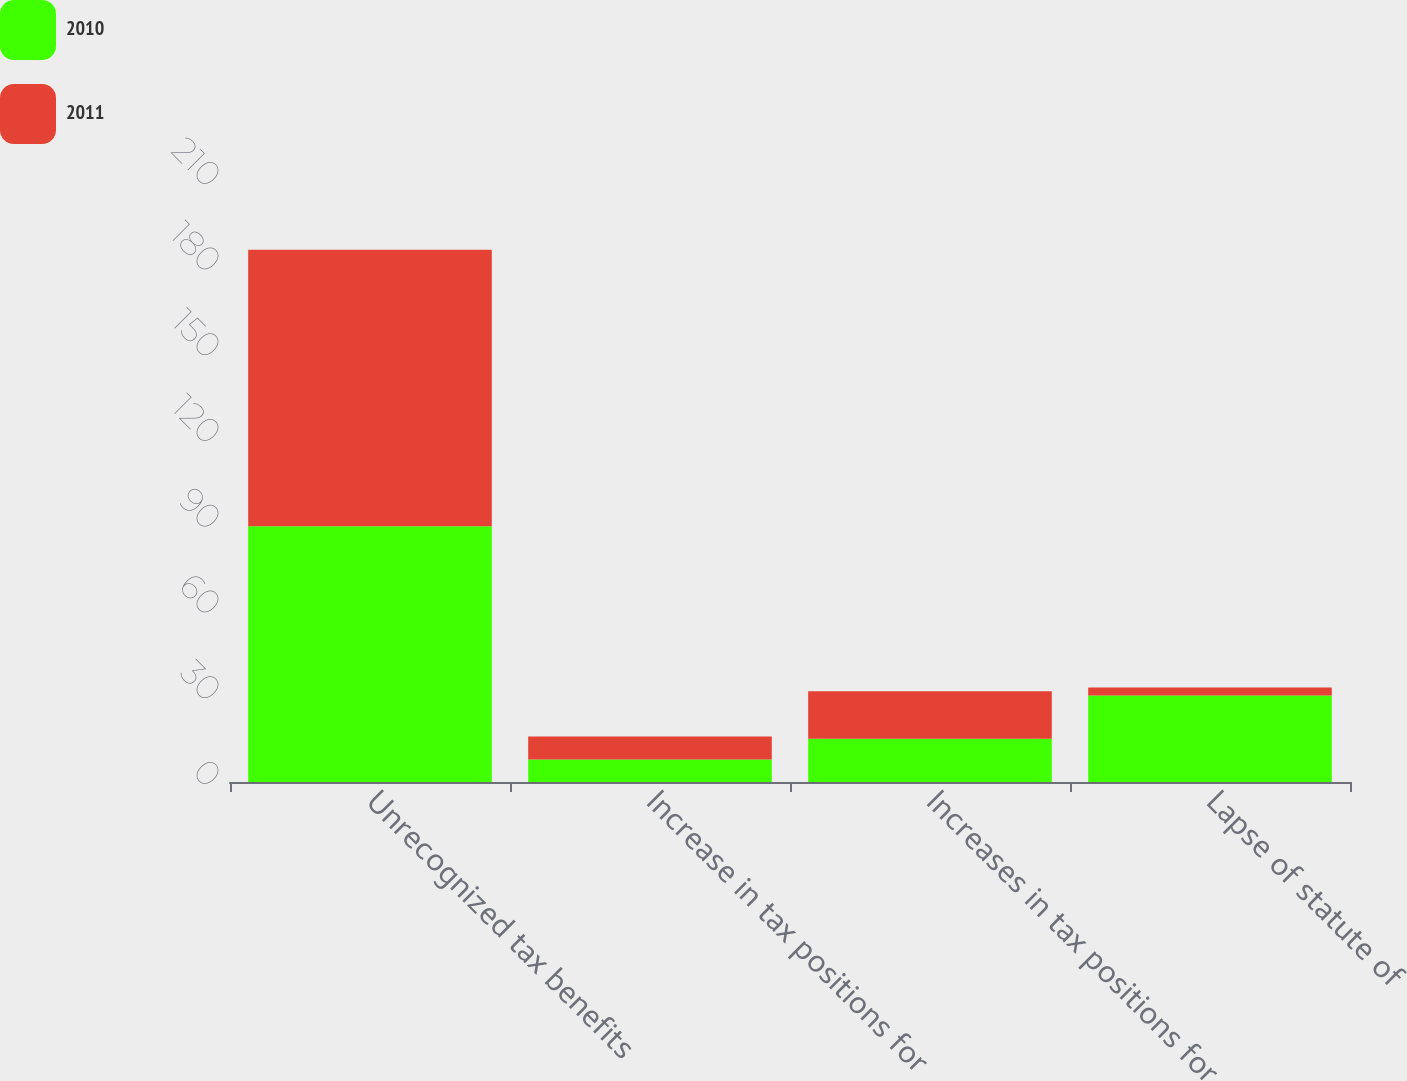<chart> <loc_0><loc_0><loc_500><loc_500><stacked_bar_chart><ecel><fcel>Unrecognized tax benefits<fcel>Increase in tax positions for<fcel>Increases in tax positions for<fcel>Lapse of statute of<nl><fcel>2010<fcel>89.5<fcel>7.9<fcel>15.1<fcel>30.3<nl><fcel>2011<fcel>96.8<fcel>8<fcel>16.7<fcel>2.8<nl></chart> 